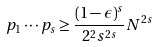<formula> <loc_0><loc_0><loc_500><loc_500>p _ { 1 } \cdots p _ { s } \geq \frac { ( 1 - \epsilon ) ^ { s } } { 2 ^ { 2 } s ^ { 2 s } } N ^ { 2 s }</formula> 